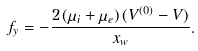<formula> <loc_0><loc_0><loc_500><loc_500>f _ { y } = - \frac { 2 \, ( \mu _ { i } + \mu _ { e } ) \, ( V ^ { ( 0 ) } - V ) } { x _ { w } } .</formula> 